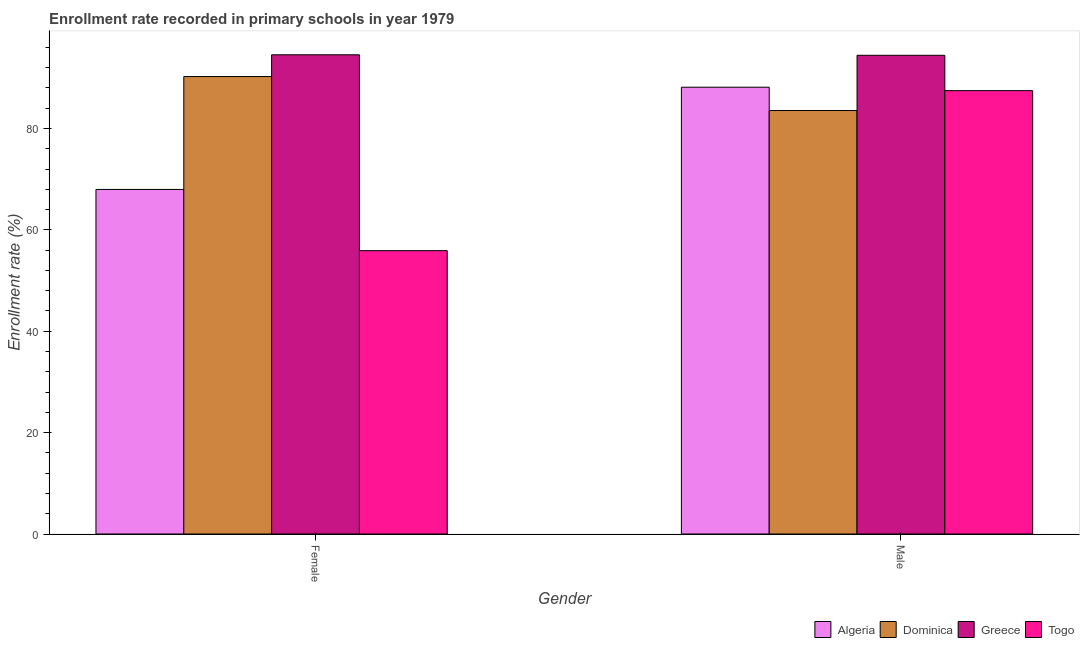How many different coloured bars are there?
Make the answer very short. 4. How many groups of bars are there?
Provide a succinct answer. 2. Are the number of bars per tick equal to the number of legend labels?
Offer a very short reply. Yes. How many bars are there on the 2nd tick from the right?
Your answer should be very brief. 4. What is the label of the 1st group of bars from the left?
Your response must be concise. Female. What is the enrollment rate of female students in Algeria?
Provide a short and direct response. 67.97. Across all countries, what is the maximum enrollment rate of female students?
Offer a very short reply. 94.54. Across all countries, what is the minimum enrollment rate of male students?
Provide a succinct answer. 83.55. In which country was the enrollment rate of male students minimum?
Make the answer very short. Dominica. What is the total enrollment rate of female students in the graph?
Provide a short and direct response. 308.66. What is the difference between the enrollment rate of female students in Togo and that in Algeria?
Make the answer very short. -12.08. What is the difference between the enrollment rate of male students in Greece and the enrollment rate of female students in Algeria?
Your response must be concise. 26.46. What is the average enrollment rate of female students per country?
Offer a terse response. 77.16. What is the difference between the enrollment rate of female students and enrollment rate of male students in Togo?
Give a very brief answer. -31.57. What is the ratio of the enrollment rate of male students in Togo to that in Algeria?
Offer a very short reply. 0.99. Is the enrollment rate of male students in Algeria less than that in Dominica?
Make the answer very short. No. What does the 2nd bar from the left in Male represents?
Your answer should be compact. Dominica. What does the 4th bar from the right in Female represents?
Offer a very short reply. Algeria. How many bars are there?
Ensure brevity in your answer.  8. Are all the bars in the graph horizontal?
Give a very brief answer. No. What is the difference between two consecutive major ticks on the Y-axis?
Offer a very short reply. 20. Where does the legend appear in the graph?
Offer a very short reply. Bottom right. How many legend labels are there?
Offer a terse response. 4. What is the title of the graph?
Offer a very short reply. Enrollment rate recorded in primary schools in year 1979. What is the label or title of the X-axis?
Offer a terse response. Gender. What is the label or title of the Y-axis?
Your response must be concise. Enrollment rate (%). What is the Enrollment rate (%) in Algeria in Female?
Offer a terse response. 67.97. What is the Enrollment rate (%) in Dominica in Female?
Give a very brief answer. 90.24. What is the Enrollment rate (%) of Greece in Female?
Offer a terse response. 94.54. What is the Enrollment rate (%) in Togo in Female?
Your response must be concise. 55.9. What is the Enrollment rate (%) in Algeria in Male?
Your answer should be very brief. 88.14. What is the Enrollment rate (%) of Dominica in Male?
Your answer should be very brief. 83.55. What is the Enrollment rate (%) in Greece in Male?
Keep it short and to the point. 94.44. What is the Enrollment rate (%) of Togo in Male?
Ensure brevity in your answer.  87.47. Across all Gender, what is the maximum Enrollment rate (%) of Algeria?
Offer a very short reply. 88.14. Across all Gender, what is the maximum Enrollment rate (%) of Dominica?
Make the answer very short. 90.24. Across all Gender, what is the maximum Enrollment rate (%) in Greece?
Your response must be concise. 94.54. Across all Gender, what is the maximum Enrollment rate (%) in Togo?
Provide a short and direct response. 87.47. Across all Gender, what is the minimum Enrollment rate (%) in Algeria?
Make the answer very short. 67.97. Across all Gender, what is the minimum Enrollment rate (%) in Dominica?
Provide a short and direct response. 83.55. Across all Gender, what is the minimum Enrollment rate (%) of Greece?
Your answer should be compact. 94.44. Across all Gender, what is the minimum Enrollment rate (%) of Togo?
Your response must be concise. 55.9. What is the total Enrollment rate (%) in Algeria in the graph?
Your response must be concise. 156.12. What is the total Enrollment rate (%) of Dominica in the graph?
Give a very brief answer. 173.79. What is the total Enrollment rate (%) in Greece in the graph?
Give a very brief answer. 188.98. What is the total Enrollment rate (%) in Togo in the graph?
Your answer should be very brief. 143.37. What is the difference between the Enrollment rate (%) in Algeria in Female and that in Male?
Your answer should be compact. -20.17. What is the difference between the Enrollment rate (%) in Dominica in Female and that in Male?
Ensure brevity in your answer.  6.7. What is the difference between the Enrollment rate (%) in Greece in Female and that in Male?
Make the answer very short. 0.1. What is the difference between the Enrollment rate (%) of Togo in Female and that in Male?
Make the answer very short. -31.57. What is the difference between the Enrollment rate (%) in Algeria in Female and the Enrollment rate (%) in Dominica in Male?
Provide a short and direct response. -15.57. What is the difference between the Enrollment rate (%) in Algeria in Female and the Enrollment rate (%) in Greece in Male?
Provide a short and direct response. -26.46. What is the difference between the Enrollment rate (%) of Algeria in Female and the Enrollment rate (%) of Togo in Male?
Make the answer very short. -19.49. What is the difference between the Enrollment rate (%) of Dominica in Female and the Enrollment rate (%) of Greece in Male?
Keep it short and to the point. -4.2. What is the difference between the Enrollment rate (%) of Dominica in Female and the Enrollment rate (%) of Togo in Male?
Your response must be concise. 2.78. What is the difference between the Enrollment rate (%) in Greece in Female and the Enrollment rate (%) in Togo in Male?
Provide a succinct answer. 7.07. What is the average Enrollment rate (%) in Algeria per Gender?
Your response must be concise. 78.06. What is the average Enrollment rate (%) of Dominica per Gender?
Keep it short and to the point. 86.89. What is the average Enrollment rate (%) of Greece per Gender?
Offer a terse response. 94.49. What is the average Enrollment rate (%) of Togo per Gender?
Your answer should be compact. 71.68. What is the difference between the Enrollment rate (%) of Algeria and Enrollment rate (%) of Dominica in Female?
Give a very brief answer. -22.27. What is the difference between the Enrollment rate (%) of Algeria and Enrollment rate (%) of Greece in Female?
Provide a succinct answer. -26.57. What is the difference between the Enrollment rate (%) of Algeria and Enrollment rate (%) of Togo in Female?
Offer a very short reply. 12.08. What is the difference between the Enrollment rate (%) of Dominica and Enrollment rate (%) of Greece in Female?
Offer a terse response. -4.3. What is the difference between the Enrollment rate (%) in Dominica and Enrollment rate (%) in Togo in Female?
Provide a short and direct response. 34.35. What is the difference between the Enrollment rate (%) in Greece and Enrollment rate (%) in Togo in Female?
Offer a very short reply. 38.64. What is the difference between the Enrollment rate (%) of Algeria and Enrollment rate (%) of Dominica in Male?
Your response must be concise. 4.6. What is the difference between the Enrollment rate (%) of Algeria and Enrollment rate (%) of Greece in Male?
Ensure brevity in your answer.  -6.3. What is the difference between the Enrollment rate (%) in Algeria and Enrollment rate (%) in Togo in Male?
Provide a succinct answer. 0.67. What is the difference between the Enrollment rate (%) of Dominica and Enrollment rate (%) of Greece in Male?
Your response must be concise. -10.89. What is the difference between the Enrollment rate (%) of Dominica and Enrollment rate (%) of Togo in Male?
Provide a succinct answer. -3.92. What is the difference between the Enrollment rate (%) of Greece and Enrollment rate (%) of Togo in Male?
Ensure brevity in your answer.  6.97. What is the ratio of the Enrollment rate (%) of Algeria in Female to that in Male?
Offer a very short reply. 0.77. What is the ratio of the Enrollment rate (%) of Dominica in Female to that in Male?
Make the answer very short. 1.08. What is the ratio of the Enrollment rate (%) of Greece in Female to that in Male?
Your response must be concise. 1. What is the ratio of the Enrollment rate (%) of Togo in Female to that in Male?
Your answer should be very brief. 0.64. What is the difference between the highest and the second highest Enrollment rate (%) of Algeria?
Your response must be concise. 20.17. What is the difference between the highest and the second highest Enrollment rate (%) in Dominica?
Provide a short and direct response. 6.7. What is the difference between the highest and the second highest Enrollment rate (%) of Greece?
Provide a short and direct response. 0.1. What is the difference between the highest and the second highest Enrollment rate (%) in Togo?
Your response must be concise. 31.57. What is the difference between the highest and the lowest Enrollment rate (%) in Algeria?
Ensure brevity in your answer.  20.17. What is the difference between the highest and the lowest Enrollment rate (%) of Dominica?
Ensure brevity in your answer.  6.7. What is the difference between the highest and the lowest Enrollment rate (%) in Greece?
Your answer should be very brief. 0.1. What is the difference between the highest and the lowest Enrollment rate (%) in Togo?
Ensure brevity in your answer.  31.57. 